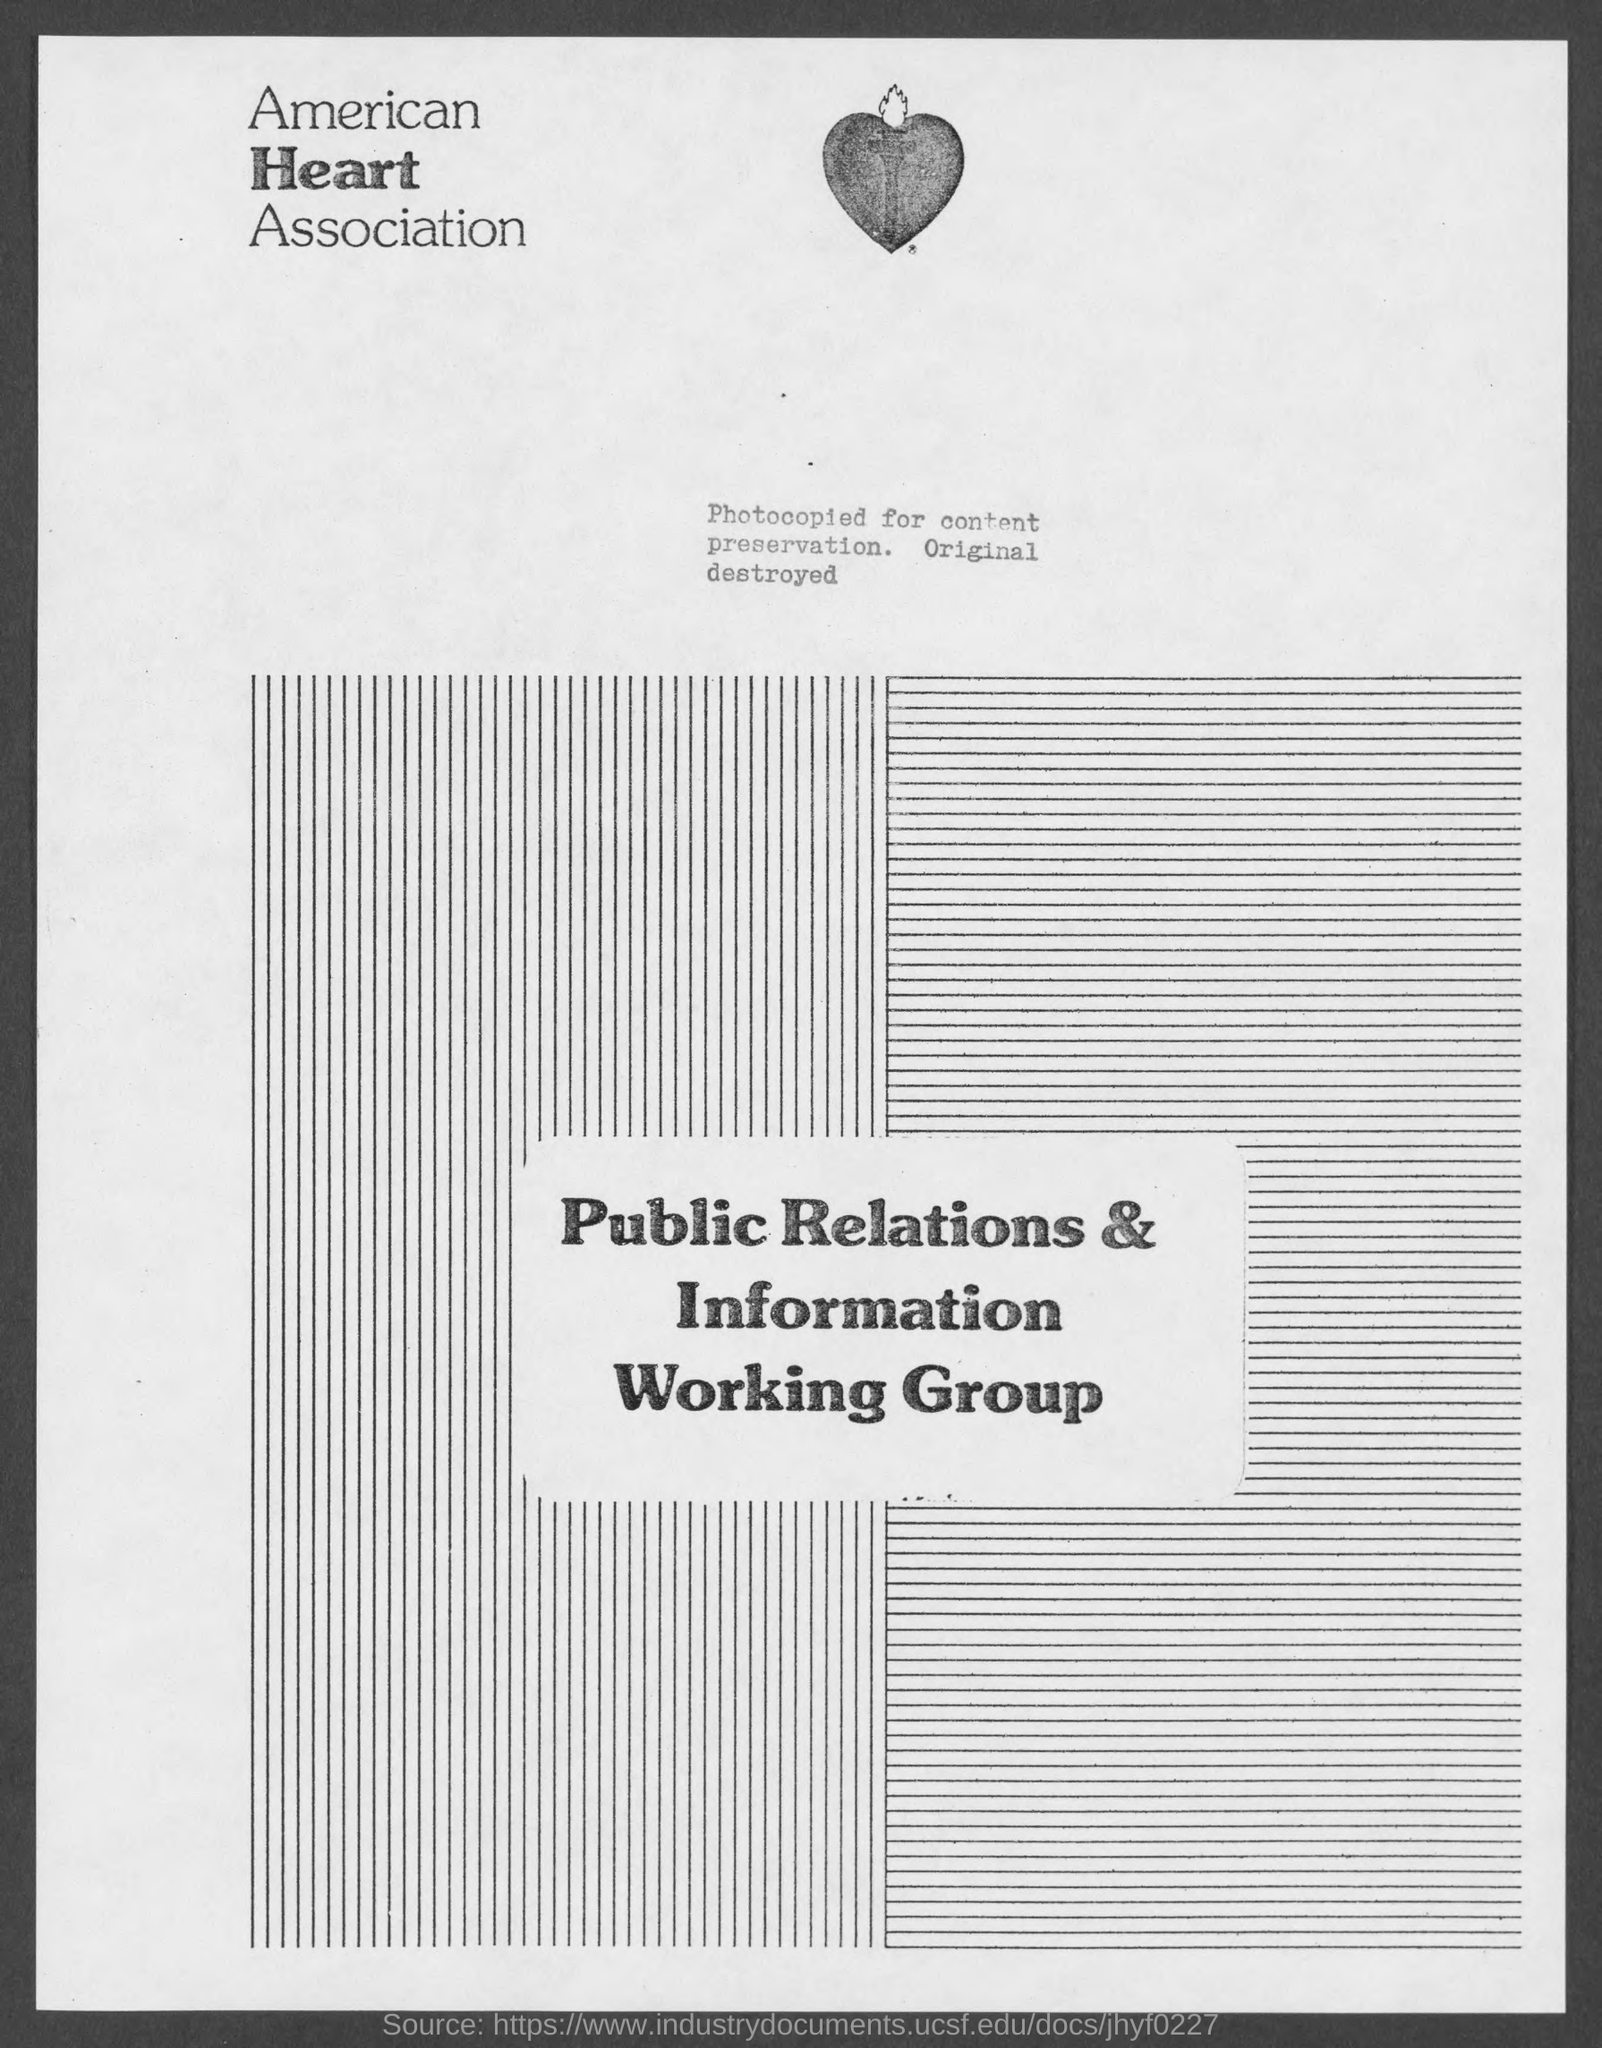What is the name of the association mentioned in the given page ?
Provide a short and direct response. American heart association. 